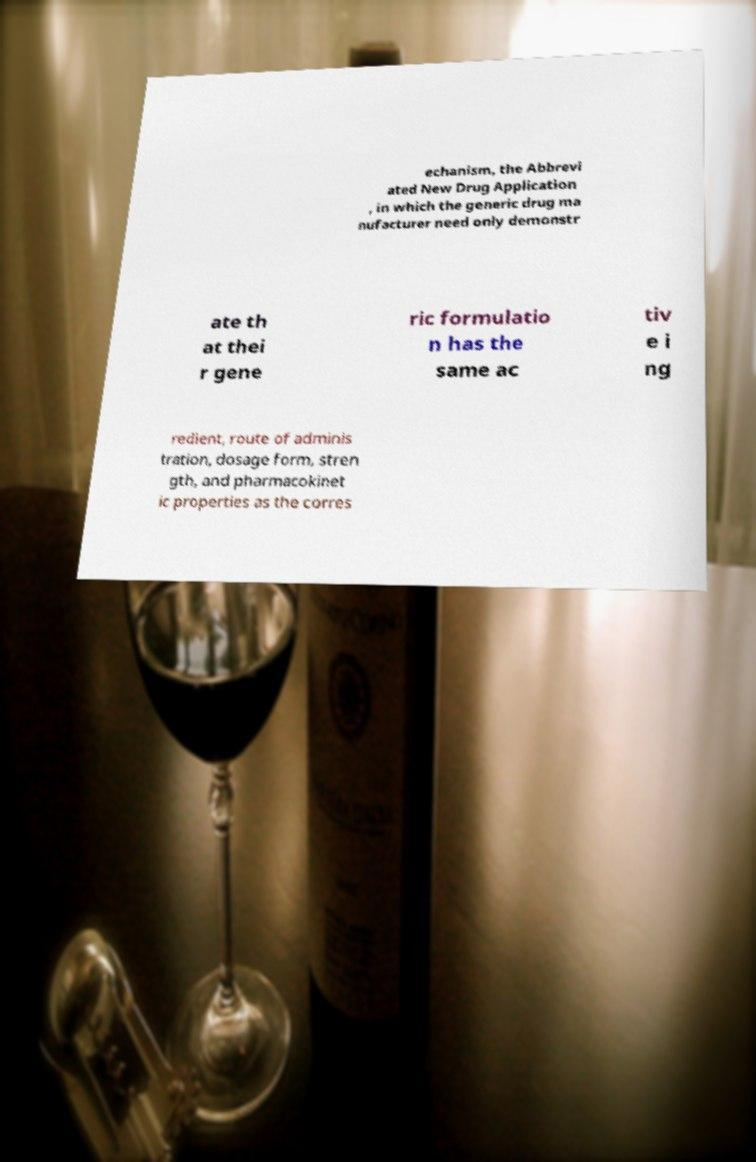For documentation purposes, I need the text within this image transcribed. Could you provide that? echanism, the Abbrevi ated New Drug Application , in which the generic drug ma nufacturer need only demonstr ate th at thei r gene ric formulatio n has the same ac tiv e i ng redient, route of adminis tration, dosage form, stren gth, and pharmacokinet ic properties as the corres 